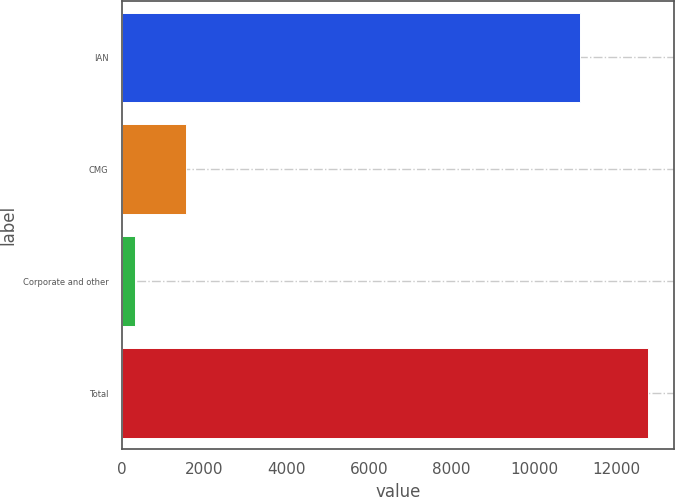<chart> <loc_0><loc_0><loc_500><loc_500><bar_chart><fcel>IAN<fcel>CMG<fcel>Corporate and other<fcel>Total<nl><fcel>11111.2<fcel>1562.27<fcel>319.5<fcel>12747.2<nl></chart> 